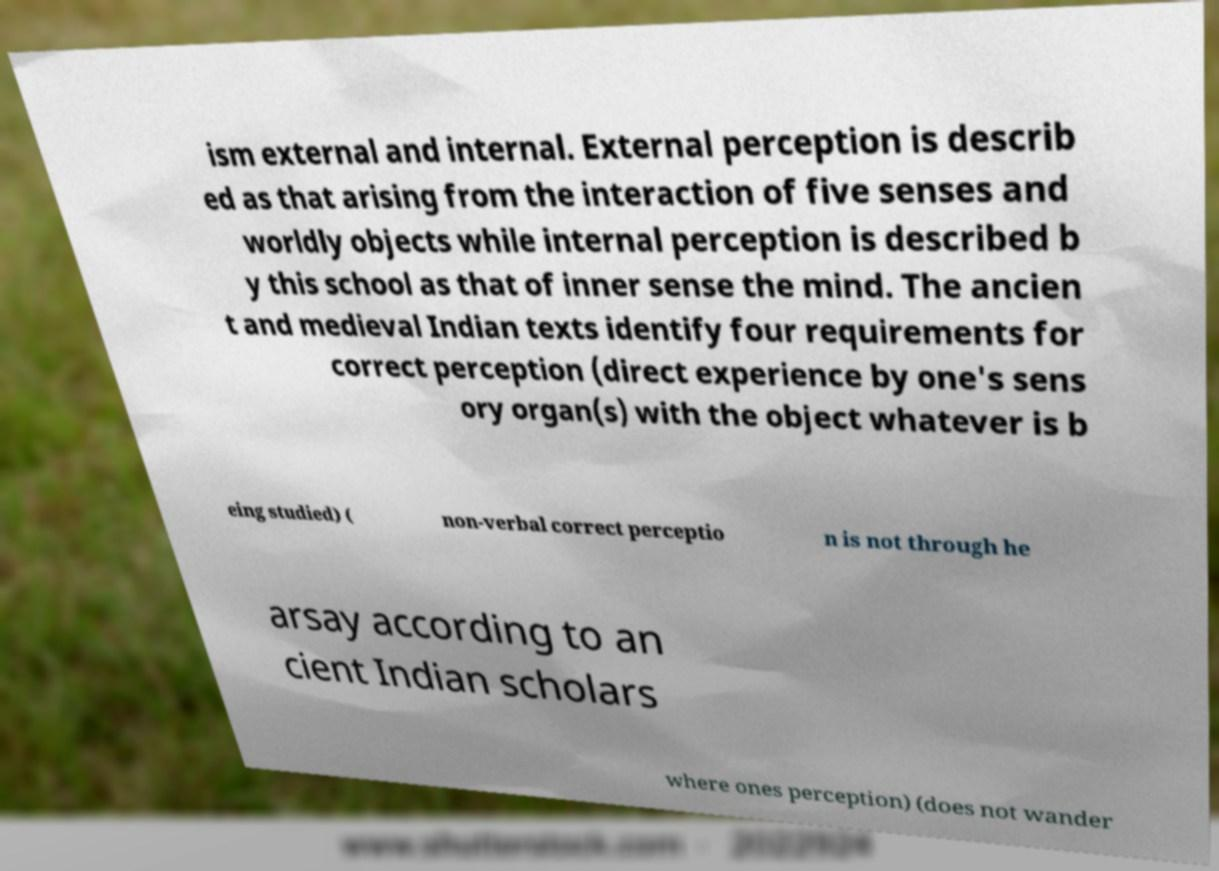What messages or text are displayed in this image? I need them in a readable, typed format. ism external and internal. External perception is describ ed as that arising from the interaction of five senses and worldly objects while internal perception is described b y this school as that of inner sense the mind. The ancien t and medieval Indian texts identify four requirements for correct perception (direct experience by one's sens ory organ(s) with the object whatever is b eing studied) ( non-verbal correct perceptio n is not through he arsay according to an cient Indian scholars where ones perception) (does not wander 